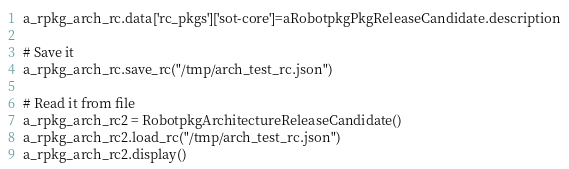<code> <loc_0><loc_0><loc_500><loc_500><_Python_>a_rpkg_arch_rc.data['rc_pkgs']['sot-core']=aRobotpkgPkgReleaseCandidate.description

# Save it
a_rpkg_arch_rc.save_rc("/tmp/arch_test_rc.json")

# Read it from file
a_rpkg_arch_rc2 = RobotpkgArchitectureReleaseCandidate()
a_rpkg_arch_rc2.load_rc("/tmp/arch_test_rc.json")
a_rpkg_arch_rc2.display()
</code> 